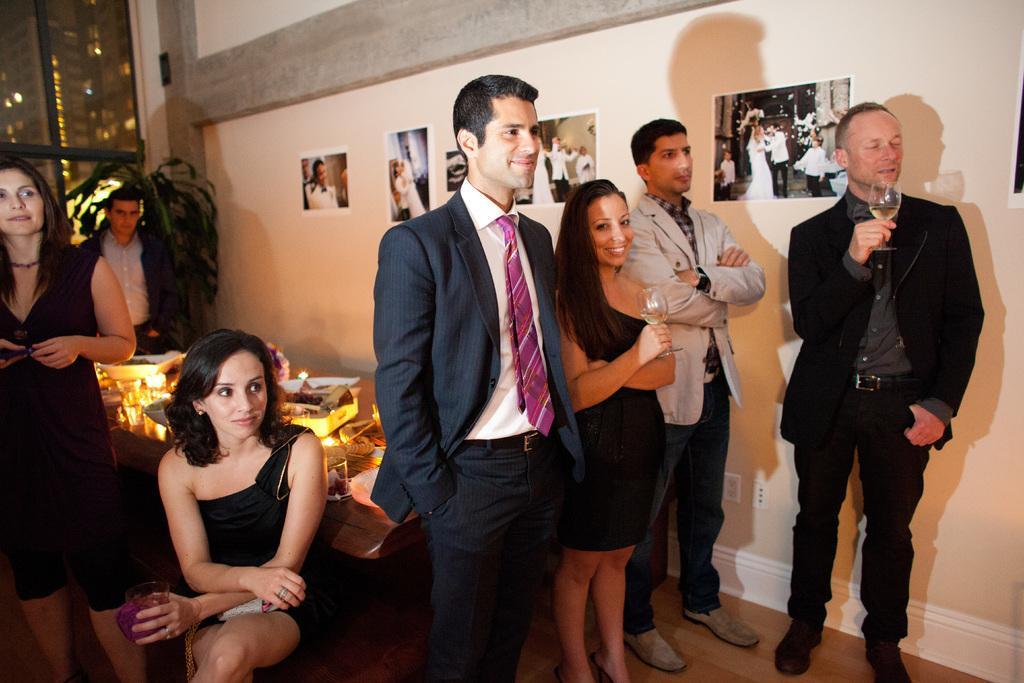Describe this image in one or two sentences. In this picture we can see seven people, three people are holding glasses with their hands and a woman sitting. In the background we can see photos on the wall, window, plant and some objects. 